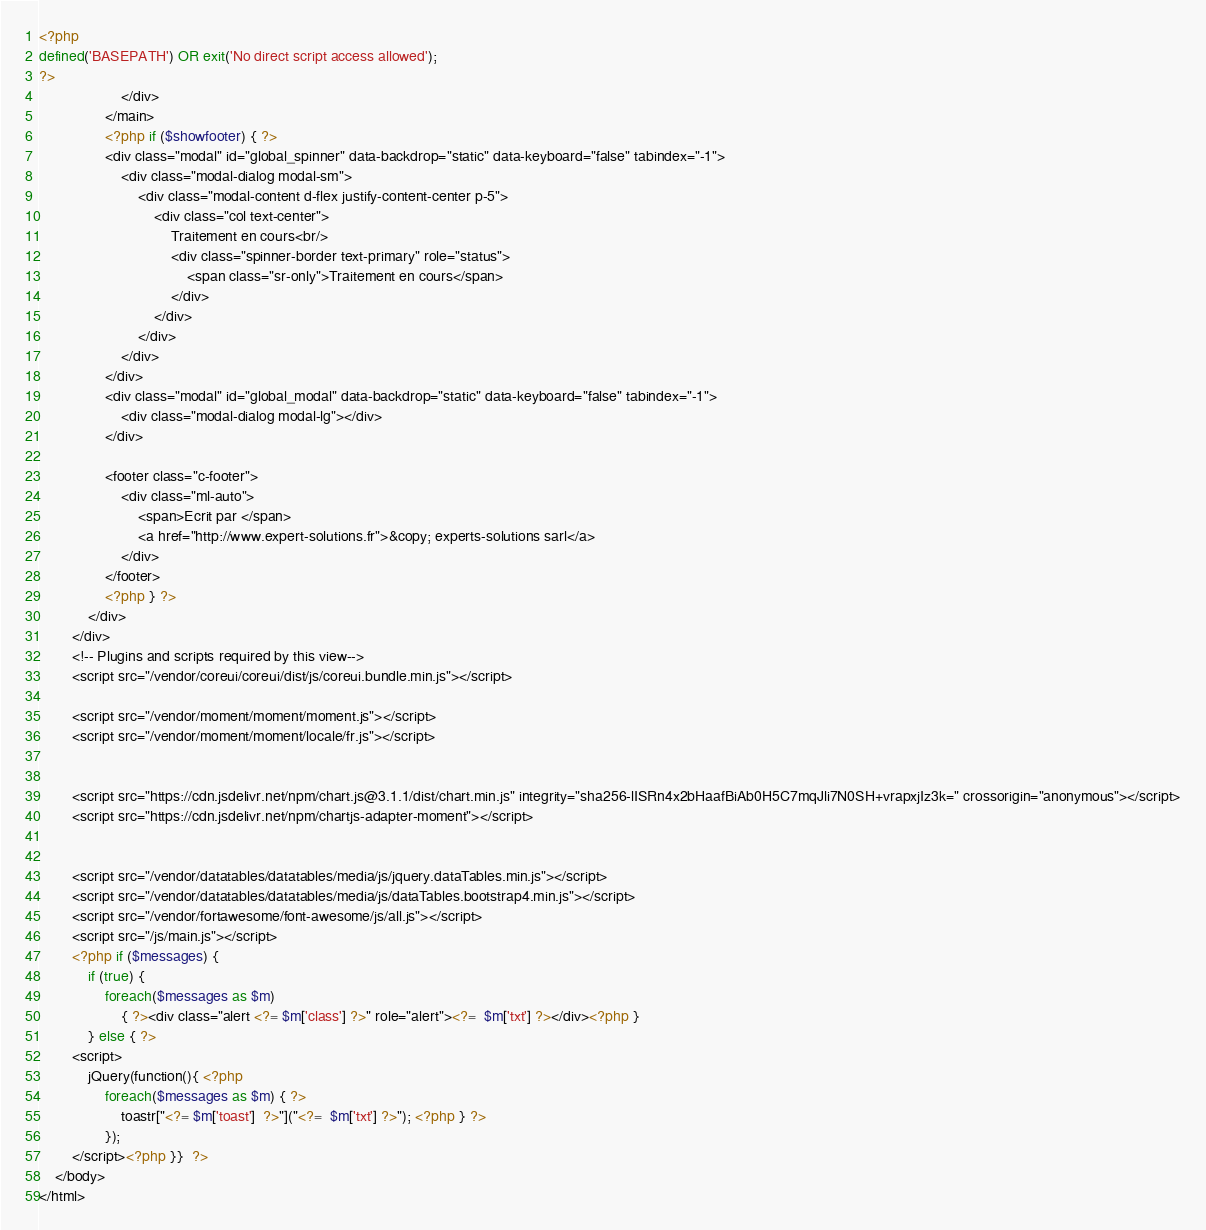<code> <loc_0><loc_0><loc_500><loc_500><_PHP_><?php
defined('BASEPATH') OR exit('No direct script access allowed');
?>
          			</div>
        		</main>
				<?php if ($showfooter) { ?>
				<div class="modal" id="global_spinner" data-backdrop="static" data-keyboard="false" tabindex="-1">
					<div class="modal-dialog modal-sm">
						<div class="modal-content d-flex justify-content-center p-5">
							<div class="col text-center">
								Traitement en cours<br/>
								<div class="spinner-border text-primary" role="status">
									<span class="sr-only">Traitement en cours</span>
								</div>
							</div>
						</div>
					</div>
				</div>
				<div class="modal" id="global_modal" data-backdrop="static" data-keyboard="false" tabindex="-1">
					<div class="modal-dialog modal-lg"></div>
				</div>
					
				<footer class="c-footer">
					<div class="ml-auto">
						<span>Ecrit par </span>
						<a href="http://www.expert-solutions.fr">&copy; experts-solutions sarl</a>
					</div>
				</footer>
				<?php } ?> 
			</div>
	    </div>
		<!-- Plugins and scripts required by this view-->
		<script src="/vendor/coreui/coreui/dist/js/coreui.bundle.min.js"></script>
		
		<script src="/vendor/moment/moment/moment.js"></script>
		<script src="/vendor/moment/moment/locale/fr.js"></script>


		<script src="https://cdn.jsdelivr.net/npm/chart.js@3.1.1/dist/chart.min.js" integrity="sha256-lISRn4x2bHaafBiAb0H5C7mqJli7N0SH+vrapxjIz3k=" crossorigin="anonymous"></script>
		<script src="https://cdn.jsdelivr.net/npm/chartjs-adapter-moment"></script>


		<script src="/vendor/datatables/datatables/media/js/jquery.dataTables.min.js"></script>
		<script src="/vendor/datatables/datatables/media/js/dataTables.bootstrap4.min.js"></script>
		<script src="/vendor/fortawesome/font-awesome/js/all.js"></script>
		<script src="/js/main.js"></script>
		<?php if ($messages) {
			if (true) {
				foreach($messages as $m)
					{ ?><div class="alert <?= $m['class'] ?>" role="alert"><?=  $m['txt'] ?></div><?php } 
			} else { ?>
		<script>
			jQuery(function(){ <?php
				foreach($messages as $m) { ?>
					toastr["<?= $m['toast']  ?>"]("<?=  $m['txt'] ?>"); <?php } ?>
				});
		</script><?php }}  ?>
	</body>
</html>
</code> 